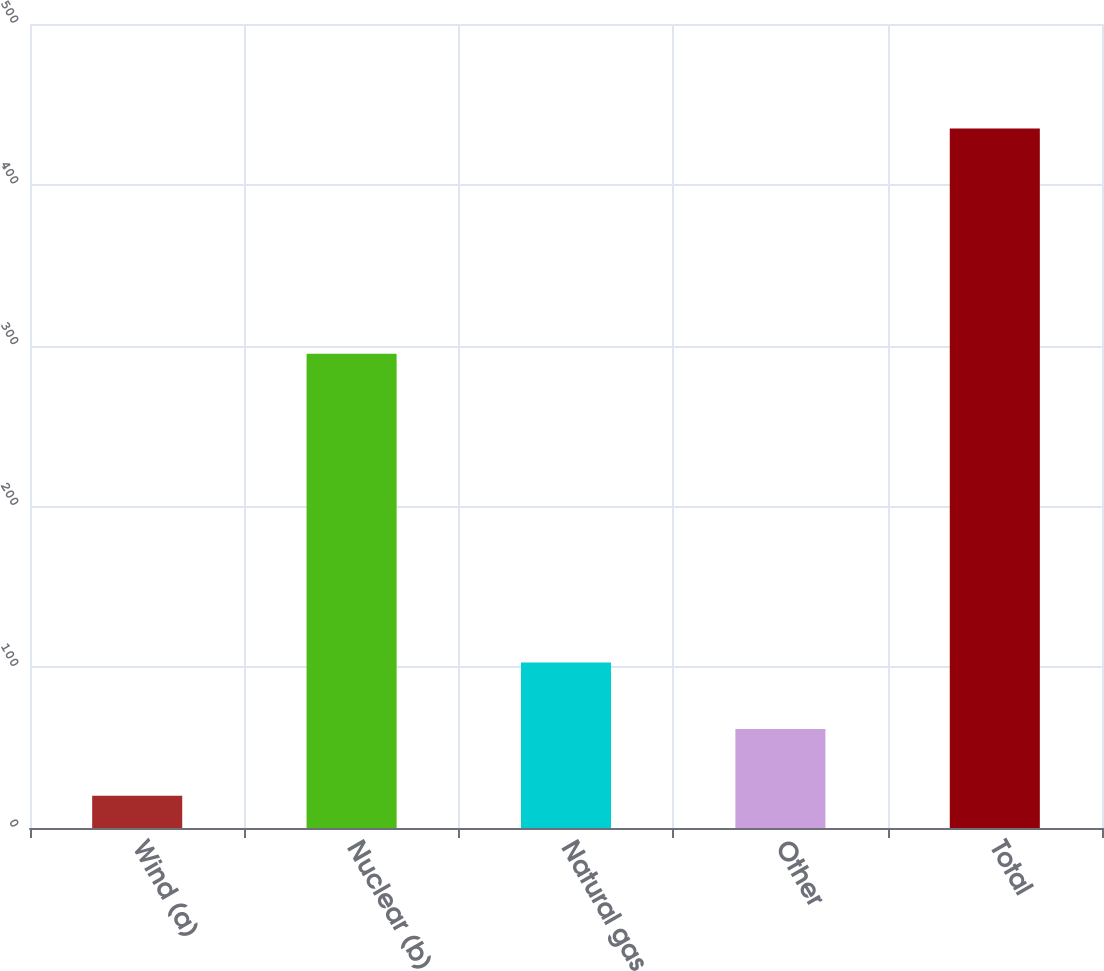Convert chart. <chart><loc_0><loc_0><loc_500><loc_500><bar_chart><fcel>Wind (a)<fcel>Nuclear (b)<fcel>Natural gas<fcel>Other<fcel>Total<nl><fcel>20<fcel>295<fcel>103<fcel>61.5<fcel>435<nl></chart> 